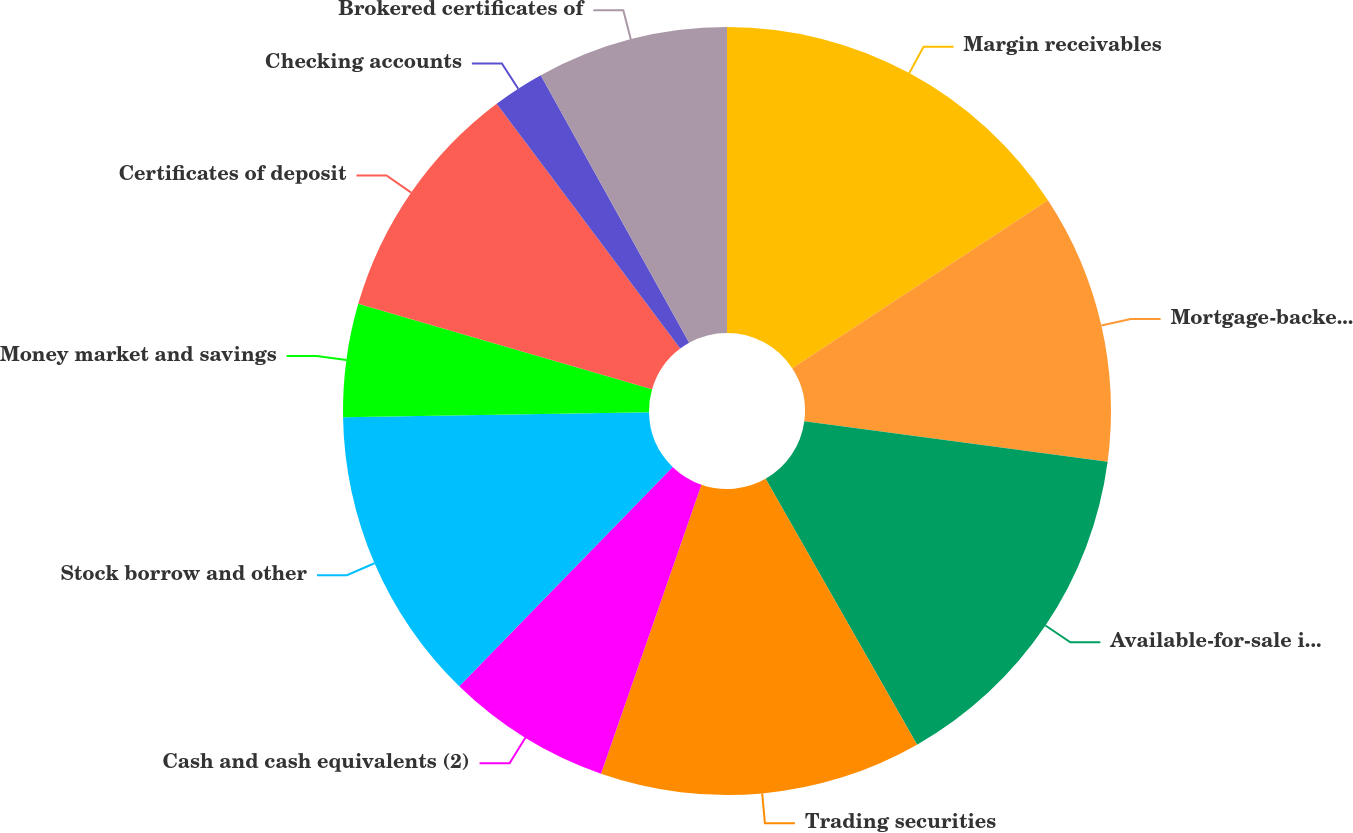Convert chart to OTSL. <chart><loc_0><loc_0><loc_500><loc_500><pie_chart><fcel>Margin receivables<fcel>Mortgage-backed and related<fcel>Available-for-sale investment<fcel>Trading securities<fcel>Cash and cash equivalents (2)<fcel>Stock borrow and other<fcel>Money market and savings<fcel>Certificates of deposit<fcel>Checking accounts<fcel>Brokered certificates of<nl><fcel>15.75%<fcel>11.36%<fcel>14.65%<fcel>13.56%<fcel>6.96%<fcel>12.46%<fcel>4.76%<fcel>10.26%<fcel>2.18%<fcel>8.06%<nl></chart> 